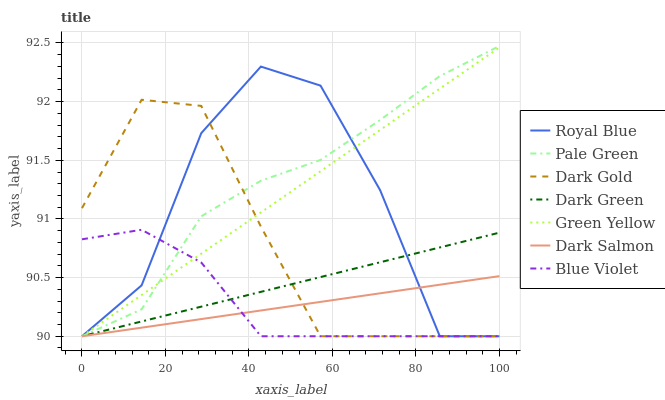Does Dark Salmon have the minimum area under the curve?
Answer yes or no. Yes. Does Pale Green have the maximum area under the curve?
Answer yes or no. Yes. Does Royal Blue have the minimum area under the curve?
Answer yes or no. No. Does Royal Blue have the maximum area under the curve?
Answer yes or no. No. Is Dark Green the smoothest?
Answer yes or no. Yes. Is Royal Blue the roughest?
Answer yes or no. Yes. Is Dark Salmon the smoothest?
Answer yes or no. No. Is Dark Salmon the roughest?
Answer yes or no. No. Does Dark Gold have the lowest value?
Answer yes or no. Yes. Does Pale Green have the highest value?
Answer yes or no. Yes. Does Royal Blue have the highest value?
Answer yes or no. No. Does Royal Blue intersect Pale Green?
Answer yes or no. Yes. Is Royal Blue less than Pale Green?
Answer yes or no. No. Is Royal Blue greater than Pale Green?
Answer yes or no. No. 